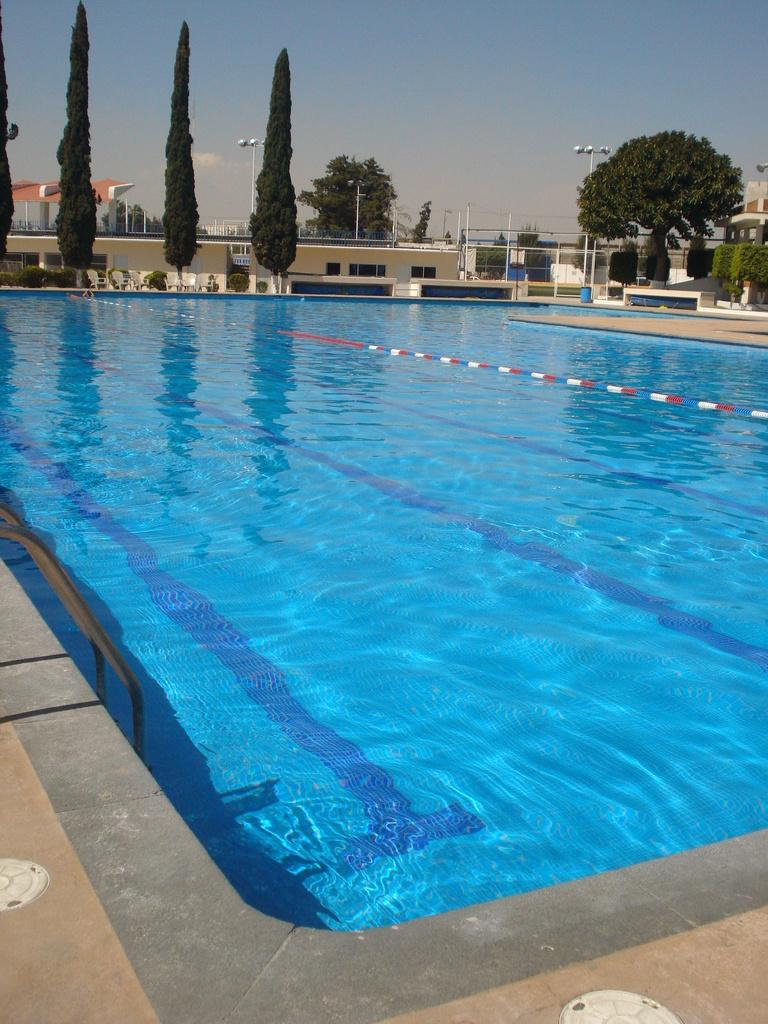What can be seen on the right side of the image? There is a swimming pool on the right side of the image. What is the swimming pool filled with? The swimming pool contains water. What is visible in the background of the image? There are trees, poles, buildings, and clouds in the blue sky in the background of the image. What type of oil can be seen in the middle of the image? There is no oil present in the image; it features a swimming pool and background elements. How is the image divided into sections? The image is not divided into sections; it is a single, continuous scene. 